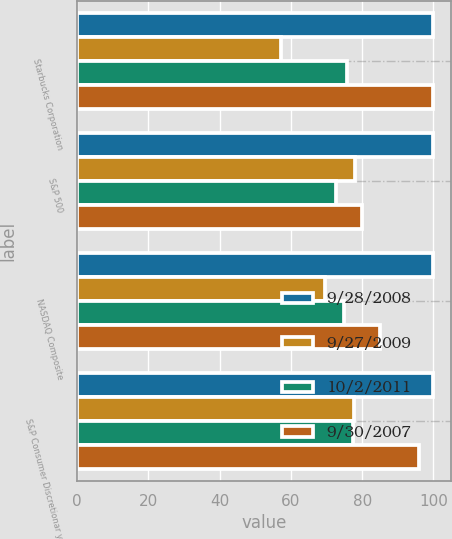<chart> <loc_0><loc_0><loc_500><loc_500><stacked_bar_chart><ecel><fcel>Starbucks Corporation<fcel>S&P 500<fcel>NASDAQ Composite<fcel>S&P Consumer Discretionar y<nl><fcel>9/28/2008<fcel>100<fcel>100<fcel>100<fcel>100<nl><fcel>9/27/2009<fcel>57.1<fcel>78.02<fcel>69.59<fcel>77.59<nl><fcel>10/2/2011<fcel>75.69<fcel>72.63<fcel>74.9<fcel>77.55<nl><fcel>9/30/2007<fcel>99.93<fcel>80.01<fcel>84.99<fcel>95.87<nl></chart> 